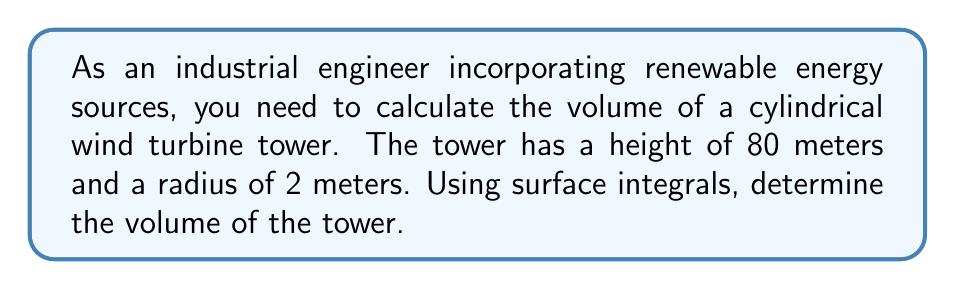Solve this math problem. To calculate the volume of the cylindrical wind turbine tower using surface integrals, we'll follow these steps:

1) For a cylinder, we can use the divergence theorem, which relates a volume integral to a surface integral:

   $$\iiint_V \nabla \cdot \mathbf{F} \, dV = \iint_S \mathbf{F} \cdot \mathbf{n} \, dS$$

2) Choose a vector field $\mathbf{F}$ such that $\nabla \cdot \mathbf{F} = 1$. A simple choice is $\mathbf{F} = \frac{1}{3}(x, y, z)$.

3) The cylinder has three surfaces: the bottom circular base, the top circular base, and the curved lateral surface. We'll evaluate the surface integral over each of these.

4) For the bottom base (z = 0):
   $\mathbf{n} = (0, 0, -1)$
   $$\iint_{S_1} \mathbf{F} \cdot \mathbf{n} \, dS = -\frac{1}{3}\iint_{S_1} z \, dS = 0$$

5) For the top base (z = 80):
   $\mathbf{n} = (0, 0, 1)$
   $$\iint_{S_2} \mathbf{F} \cdot \mathbf{n} \, dS = \frac{1}{3}\iint_{S_2} 80 \, dS = \frac{80}{3}\pi r^2 = \frac{80}{3}\pi(2^2) = \frac{320\pi}{3}$$

6) For the lateral surface:
   $\mathbf{n} = (\cos\theta, \sin\theta, 0)$
   $$\iint_{S_3} \mathbf{F} \cdot \mathbf{n} \, dS = \frac{1}{3}\int_0^{80}\int_0^{2\pi} 2(\cos^2\theta + \sin^2\theta) \, d\theta dz = \frac{1}{3}\int_0^{80}\int_0^{2\pi} 2 \, d\theta dz = \frac{320\pi}{3}$$

7) The total surface integral is the sum of these three integrals:
   $$\iint_S \mathbf{F} \cdot \mathbf{n} \, dS = 0 + \frac{320\pi}{3} + \frac{320\pi}{3} = \frac{640\pi}{3}$$

8) By the divergence theorem, this equals the volume integral of $\nabla \cdot \mathbf{F}$, which is 1:
   $$\iiint_V \nabla \cdot \mathbf{F} \, dV = \iiint_V 1 \, dV = V$$

Therefore, the volume of the cylinder is $\frac{640\pi}{3}$ cubic meters.
Answer: $\frac{640\pi}{3}$ m³ 